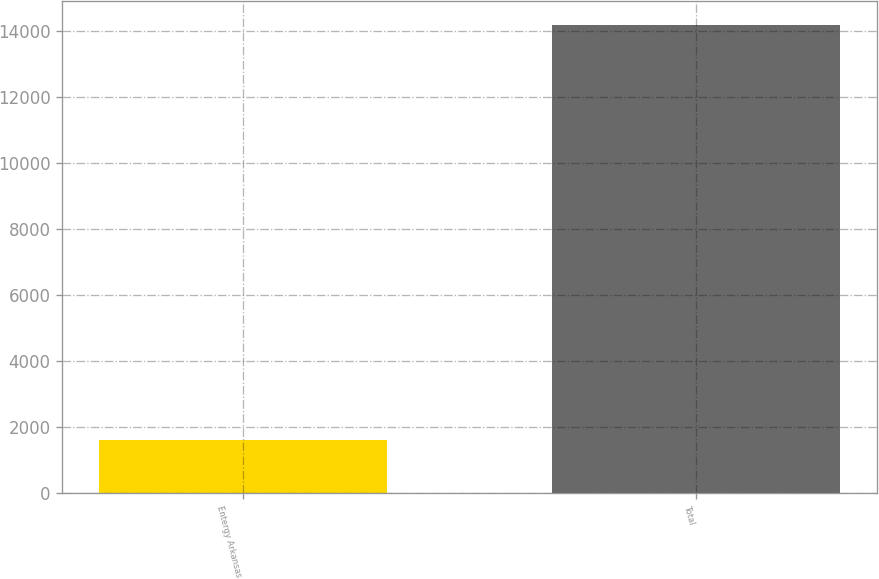<chart> <loc_0><loc_0><loc_500><loc_500><bar_chart><fcel>Entergy Arkansas<fcel>Total<nl><fcel>1613<fcel>14184<nl></chart> 